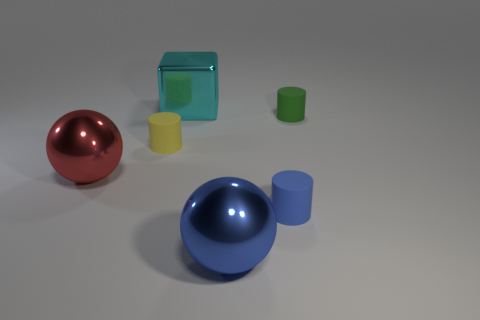Subtract all small blue matte cylinders. How many cylinders are left? 2 Add 3 tiny cyan matte cubes. How many objects exist? 9 Subtract all yellow cylinders. How many cylinders are left? 2 Subtract all spheres. How many objects are left? 4 Subtract all small green balls. Subtract all cyan objects. How many objects are left? 5 Add 3 tiny rubber objects. How many tiny rubber objects are left? 6 Add 3 large shiny cubes. How many large shiny cubes exist? 4 Subtract 1 blue cylinders. How many objects are left? 5 Subtract all yellow cylinders. Subtract all cyan cubes. How many cylinders are left? 2 